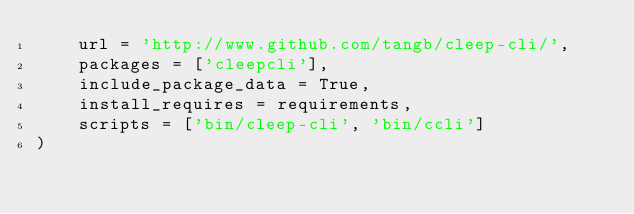Convert code to text. <code><loc_0><loc_0><loc_500><loc_500><_Python_>    url = 'http://www.github.com/tangb/cleep-cli/',
    packages = ['cleepcli'],
    include_package_data = True,
    install_requires = requirements,
    scripts = ['bin/cleep-cli', 'bin/ccli']
)

</code> 